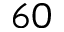<formula> <loc_0><loc_0><loc_500><loc_500>6 0</formula> 